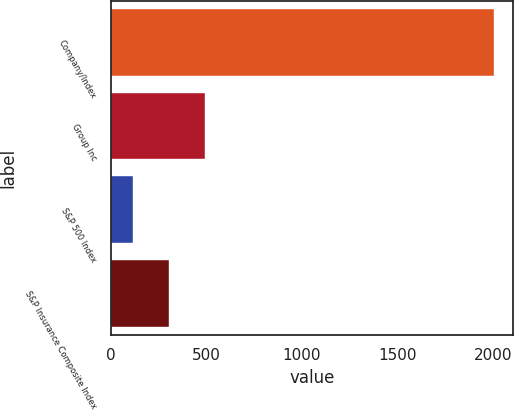Convert chart. <chart><loc_0><loc_0><loc_500><loc_500><bar_chart><fcel>Company/Index<fcel>Group Inc<fcel>S&P 500 Index<fcel>S&P Insurance Composite Index<nl><fcel>2005<fcel>494.07<fcel>116.33<fcel>305.2<nl></chart> 